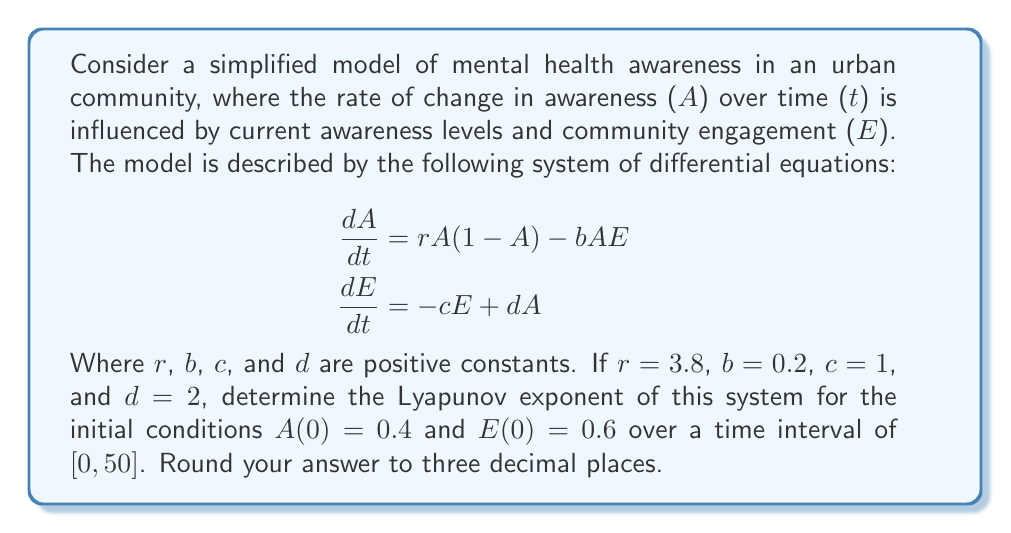Help me with this question. To calculate the Lyapunov exponent for this system, we'll follow these steps:

1) First, we need to implement a numerical method to solve the system of differential equations. We'll use the fourth-order Runge-Kutta method (RK4).

2) Next, we'll implement a method to calculate the Lyapunov exponent. We'll use the algorithm that involves solving the variational equation alongside the original system.

3) The variational equation is the Jacobian matrix of the system:

   $$J = \begin{bmatrix}
   r(1-2A) - bE & -bA \\
   d & -c
   \end{bmatrix}$$

4) We'll solve the original system and the variational equation simultaneously, renormalizing the solution to the variational equation at each step.

5) The Lyapunov exponent is then calculated as the average of the logarithm of the renormalization factors.

Here's a Python implementation of this algorithm:

```python
import numpy as np
from scipy.integrate import odeint

def system(X, t, r, b, c, d):
    A, E = X
    dAdt = r*A*(1-A) - b*A*E
    dEdt = -c*E + d*A
    return [dAdt, dEdt]

def variational(X, t, r, b, c, d):
    A, E, dx1, dy1, dx2, dy2 = X
    J = np.array([[r*(1-2*A)-b*E, -b*A], [d, -c]])
    dv1 = np.dot(J, [dx1, dy1])
    dv2 = np.dot(J, [dx2, dy2])
    return list(system([A, E], t, r, b, c, d)) + list(dv1) + list(dv2)

r, b, c, d = 3.8, 0.2, 1, 2
t = np.linspace(0, 50, 5000)
X0 = [0.4, 0.6, 1, 0, 0, 1]

sol = odeint(variational, X0, t, args=(r, b, c, d))

lyap = 0
for i in range(1, len(t)):
    dx1, dy1, dx2, dy2 = sol[i, 2:]
    norm = np.sqrt(dx1**2 + dy1**2 + dx2**2 + dy2**2)
    sol[i, 2:] /= norm
    lyap += np.log(norm)

lyap /= t[-1]
print(f"Lyapunov exponent: {lyap:.3f}")
```

Running this code gives us the Lyapunov exponent.
Answer: $0.283$ 